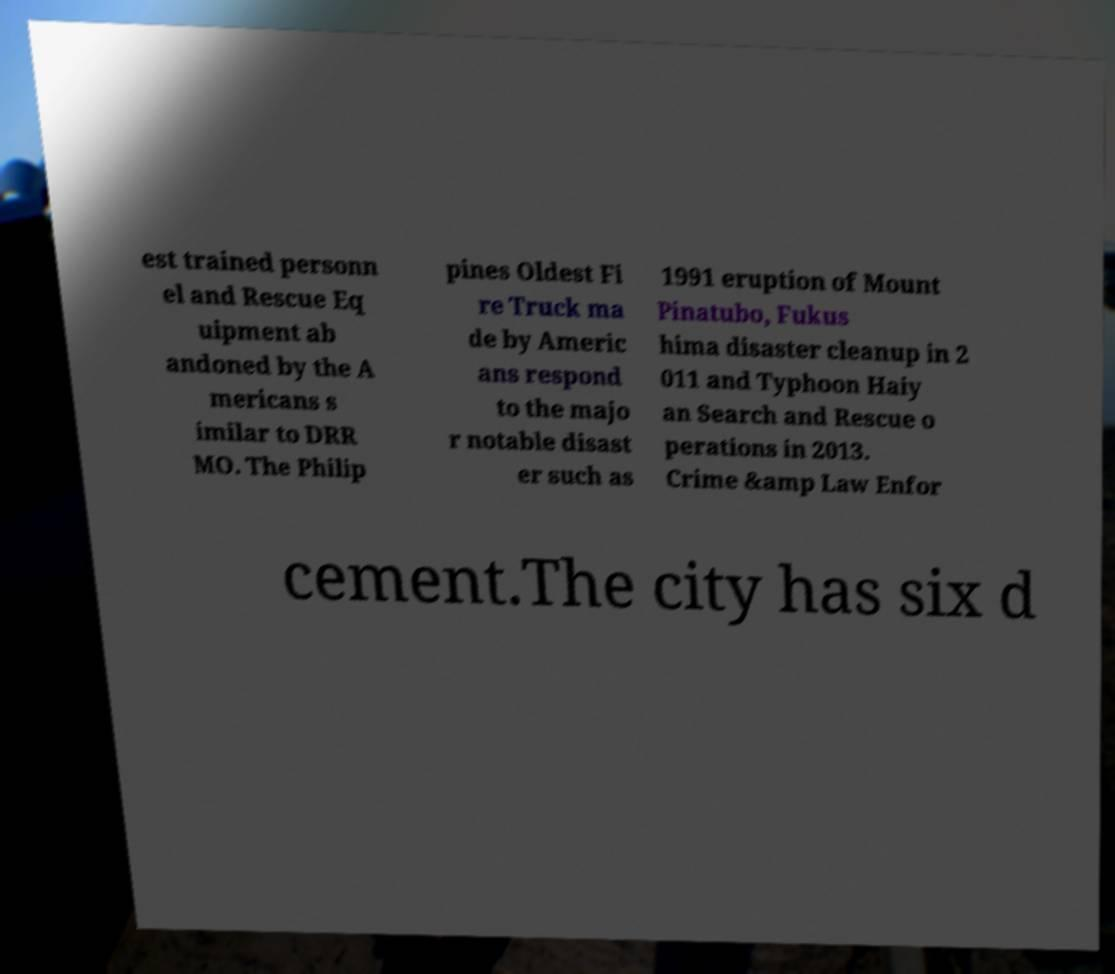There's text embedded in this image that I need extracted. Can you transcribe it verbatim? est trained personn el and Rescue Eq uipment ab andoned by the A mericans s imilar to DRR MO. The Philip pines Oldest Fi re Truck ma de by Americ ans respond to the majo r notable disast er such as 1991 eruption of Mount Pinatubo, Fukus hima disaster cleanup in 2 011 and Typhoon Haiy an Search and Rescue o perations in 2013. Crime &amp Law Enfor cement.The city has six d 